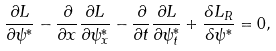<formula> <loc_0><loc_0><loc_500><loc_500>\frac { \partial L } { \partial \psi ^ { * } } - \frac { \partial } { \partial x } \frac { \partial L } { \partial \psi ^ { * } _ { x } } - \frac { \partial } { \partial t } \frac { \partial L } { \partial \psi ^ { * } _ { t } } + \frac { \delta L _ { R } } { \delta \psi ^ { * } } = 0 ,</formula> 